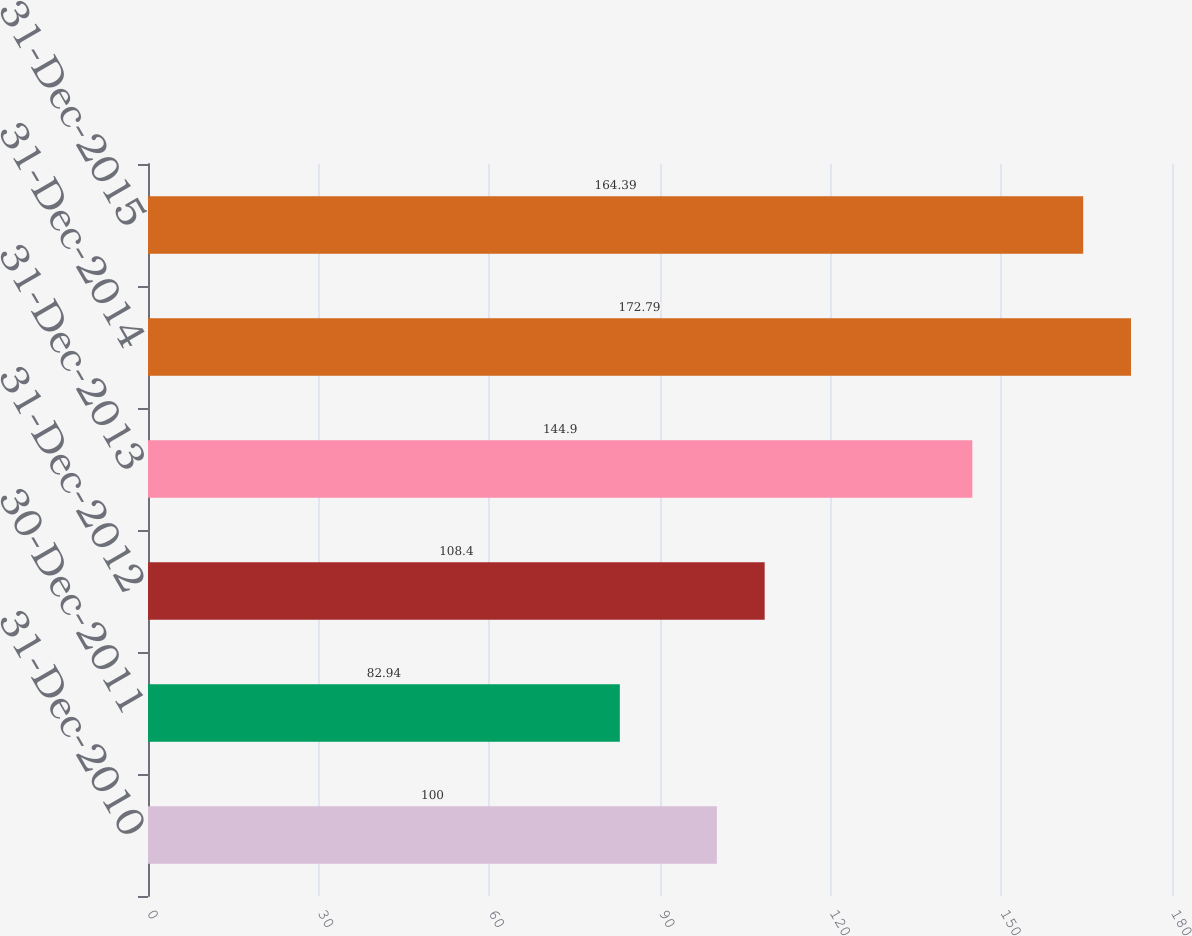Convert chart to OTSL. <chart><loc_0><loc_0><loc_500><loc_500><bar_chart><fcel>31-Dec-2010<fcel>30-Dec-2011<fcel>31-Dec-2012<fcel>31-Dec-2013<fcel>31-Dec-2014<fcel>31-Dec-2015<nl><fcel>100<fcel>82.94<fcel>108.4<fcel>144.9<fcel>172.79<fcel>164.39<nl></chart> 